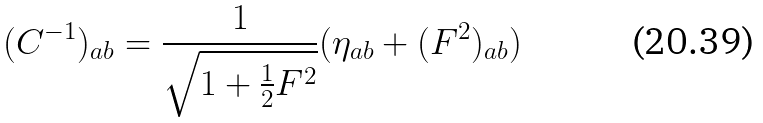Convert formula to latex. <formula><loc_0><loc_0><loc_500><loc_500>( C ^ { - 1 } ) _ { a b } = \frac { 1 } { \sqrt { 1 + \frac { 1 } { 2 } F ^ { 2 } } } ( \eta _ { a b } + ( F ^ { 2 } ) _ { a b } )</formula> 